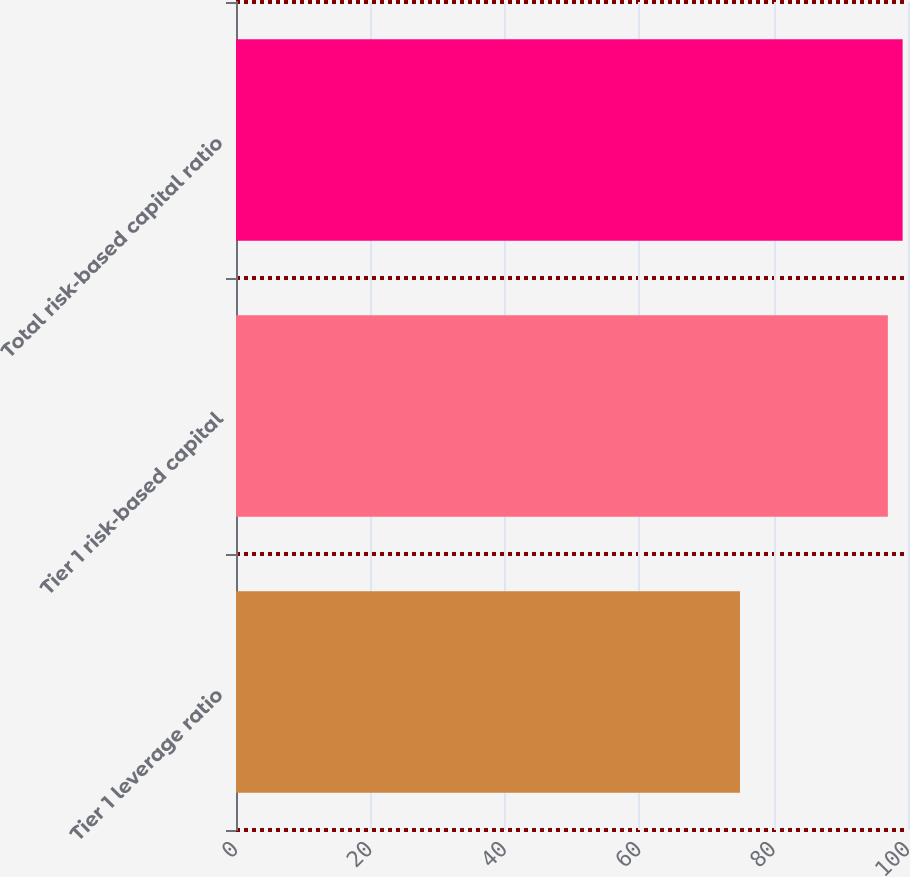Convert chart to OTSL. <chart><loc_0><loc_0><loc_500><loc_500><bar_chart><fcel>Tier 1 leverage ratio<fcel>Tier 1 risk-based capital<fcel>Total risk-based capital ratio<nl><fcel>75<fcel>97<fcel>99.2<nl></chart> 